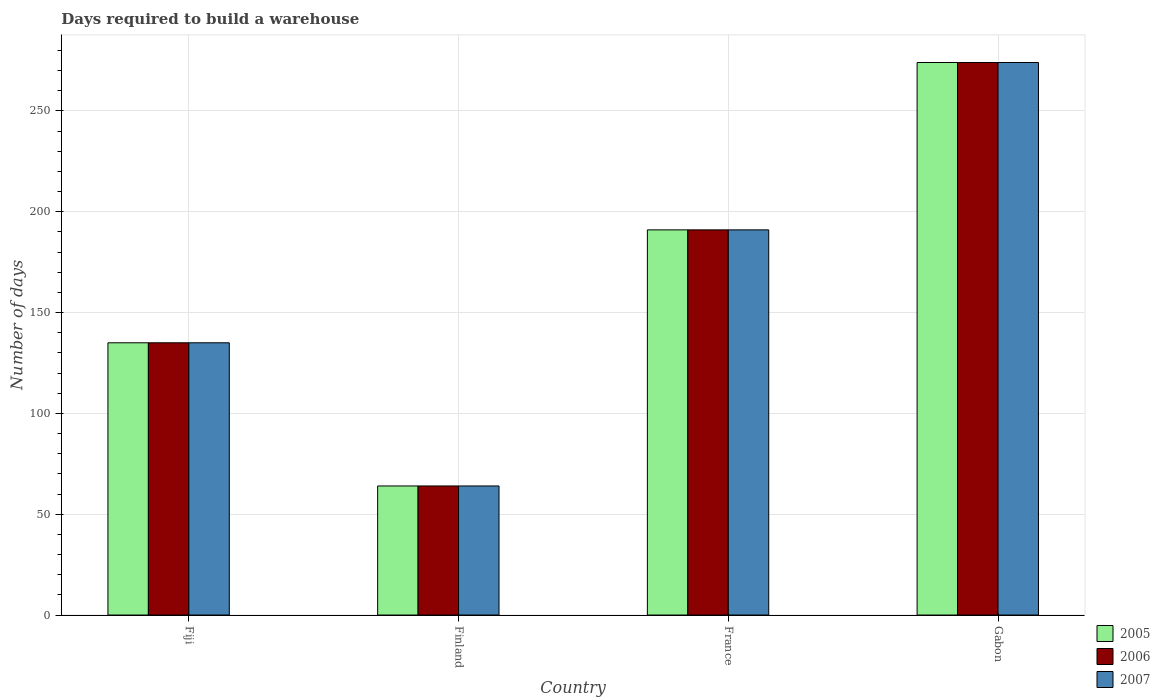Are the number of bars per tick equal to the number of legend labels?
Your answer should be very brief. Yes. How many bars are there on the 4th tick from the left?
Your answer should be compact. 3. What is the label of the 2nd group of bars from the left?
Ensure brevity in your answer.  Finland. In how many cases, is the number of bars for a given country not equal to the number of legend labels?
Offer a very short reply. 0. What is the days required to build a warehouse in in 2006 in Fiji?
Your answer should be very brief. 135. Across all countries, what is the maximum days required to build a warehouse in in 2007?
Keep it short and to the point. 274. Across all countries, what is the minimum days required to build a warehouse in in 2007?
Ensure brevity in your answer.  64. In which country was the days required to build a warehouse in in 2005 maximum?
Provide a short and direct response. Gabon. In which country was the days required to build a warehouse in in 2006 minimum?
Your response must be concise. Finland. What is the total days required to build a warehouse in in 2006 in the graph?
Keep it short and to the point. 664. What is the difference between the days required to build a warehouse in in 2005 in Fiji and that in France?
Your answer should be very brief. -56. What is the difference between the days required to build a warehouse in in 2005 in Gabon and the days required to build a warehouse in in 2006 in Finland?
Your answer should be compact. 210. What is the average days required to build a warehouse in in 2005 per country?
Your answer should be compact. 166. In how many countries, is the days required to build a warehouse in in 2005 greater than 200 days?
Offer a very short reply. 1. What is the ratio of the days required to build a warehouse in in 2007 in Finland to that in France?
Your answer should be compact. 0.34. Is the days required to build a warehouse in in 2005 in Finland less than that in Gabon?
Ensure brevity in your answer.  Yes. What is the difference between the highest and the second highest days required to build a warehouse in in 2006?
Your answer should be very brief. -139. What is the difference between the highest and the lowest days required to build a warehouse in in 2005?
Provide a short and direct response. 210. What does the 1st bar from the left in Finland represents?
Provide a succinct answer. 2005. What does the 2nd bar from the right in Gabon represents?
Your answer should be very brief. 2006. How many bars are there?
Provide a short and direct response. 12. Are the values on the major ticks of Y-axis written in scientific E-notation?
Keep it short and to the point. No. Does the graph contain any zero values?
Your response must be concise. No. Does the graph contain grids?
Ensure brevity in your answer.  Yes. How are the legend labels stacked?
Your response must be concise. Vertical. What is the title of the graph?
Your answer should be very brief. Days required to build a warehouse. Does "2000" appear as one of the legend labels in the graph?
Your response must be concise. No. What is the label or title of the X-axis?
Your answer should be very brief. Country. What is the label or title of the Y-axis?
Give a very brief answer. Number of days. What is the Number of days of 2005 in Fiji?
Keep it short and to the point. 135. What is the Number of days in 2006 in Fiji?
Your answer should be compact. 135. What is the Number of days in 2007 in Fiji?
Your response must be concise. 135. What is the Number of days of 2005 in Finland?
Your answer should be very brief. 64. What is the Number of days of 2005 in France?
Make the answer very short. 191. What is the Number of days in 2006 in France?
Provide a short and direct response. 191. What is the Number of days in 2007 in France?
Your answer should be compact. 191. What is the Number of days of 2005 in Gabon?
Keep it short and to the point. 274. What is the Number of days in 2006 in Gabon?
Your answer should be compact. 274. What is the Number of days in 2007 in Gabon?
Offer a terse response. 274. Across all countries, what is the maximum Number of days in 2005?
Keep it short and to the point. 274. Across all countries, what is the maximum Number of days of 2006?
Give a very brief answer. 274. Across all countries, what is the maximum Number of days in 2007?
Make the answer very short. 274. Across all countries, what is the minimum Number of days of 2007?
Provide a succinct answer. 64. What is the total Number of days of 2005 in the graph?
Keep it short and to the point. 664. What is the total Number of days in 2006 in the graph?
Your answer should be very brief. 664. What is the total Number of days of 2007 in the graph?
Give a very brief answer. 664. What is the difference between the Number of days of 2007 in Fiji and that in Finland?
Make the answer very short. 71. What is the difference between the Number of days of 2005 in Fiji and that in France?
Offer a terse response. -56. What is the difference between the Number of days in 2006 in Fiji and that in France?
Ensure brevity in your answer.  -56. What is the difference between the Number of days in 2007 in Fiji and that in France?
Your response must be concise. -56. What is the difference between the Number of days of 2005 in Fiji and that in Gabon?
Provide a short and direct response. -139. What is the difference between the Number of days of 2006 in Fiji and that in Gabon?
Your answer should be very brief. -139. What is the difference between the Number of days of 2007 in Fiji and that in Gabon?
Offer a very short reply. -139. What is the difference between the Number of days of 2005 in Finland and that in France?
Ensure brevity in your answer.  -127. What is the difference between the Number of days of 2006 in Finland and that in France?
Offer a very short reply. -127. What is the difference between the Number of days of 2007 in Finland and that in France?
Give a very brief answer. -127. What is the difference between the Number of days of 2005 in Finland and that in Gabon?
Your answer should be compact. -210. What is the difference between the Number of days of 2006 in Finland and that in Gabon?
Your answer should be compact. -210. What is the difference between the Number of days of 2007 in Finland and that in Gabon?
Offer a very short reply. -210. What is the difference between the Number of days of 2005 in France and that in Gabon?
Keep it short and to the point. -83. What is the difference between the Number of days in 2006 in France and that in Gabon?
Provide a succinct answer. -83. What is the difference between the Number of days of 2007 in France and that in Gabon?
Give a very brief answer. -83. What is the difference between the Number of days in 2005 in Fiji and the Number of days in 2006 in Finland?
Your answer should be compact. 71. What is the difference between the Number of days of 2005 in Fiji and the Number of days of 2007 in Finland?
Your response must be concise. 71. What is the difference between the Number of days of 2005 in Fiji and the Number of days of 2006 in France?
Provide a succinct answer. -56. What is the difference between the Number of days of 2005 in Fiji and the Number of days of 2007 in France?
Your answer should be compact. -56. What is the difference between the Number of days of 2006 in Fiji and the Number of days of 2007 in France?
Ensure brevity in your answer.  -56. What is the difference between the Number of days of 2005 in Fiji and the Number of days of 2006 in Gabon?
Offer a terse response. -139. What is the difference between the Number of days in 2005 in Fiji and the Number of days in 2007 in Gabon?
Offer a terse response. -139. What is the difference between the Number of days of 2006 in Fiji and the Number of days of 2007 in Gabon?
Ensure brevity in your answer.  -139. What is the difference between the Number of days of 2005 in Finland and the Number of days of 2006 in France?
Your answer should be compact. -127. What is the difference between the Number of days in 2005 in Finland and the Number of days in 2007 in France?
Ensure brevity in your answer.  -127. What is the difference between the Number of days in 2006 in Finland and the Number of days in 2007 in France?
Give a very brief answer. -127. What is the difference between the Number of days of 2005 in Finland and the Number of days of 2006 in Gabon?
Keep it short and to the point. -210. What is the difference between the Number of days in 2005 in Finland and the Number of days in 2007 in Gabon?
Make the answer very short. -210. What is the difference between the Number of days in 2006 in Finland and the Number of days in 2007 in Gabon?
Your response must be concise. -210. What is the difference between the Number of days of 2005 in France and the Number of days of 2006 in Gabon?
Provide a short and direct response. -83. What is the difference between the Number of days of 2005 in France and the Number of days of 2007 in Gabon?
Your response must be concise. -83. What is the difference between the Number of days in 2006 in France and the Number of days in 2007 in Gabon?
Your response must be concise. -83. What is the average Number of days of 2005 per country?
Provide a succinct answer. 166. What is the average Number of days in 2006 per country?
Provide a short and direct response. 166. What is the average Number of days in 2007 per country?
Your answer should be compact. 166. What is the difference between the Number of days of 2005 and Number of days of 2006 in Fiji?
Make the answer very short. 0. What is the difference between the Number of days of 2005 and Number of days of 2007 in Fiji?
Keep it short and to the point. 0. What is the difference between the Number of days of 2006 and Number of days of 2007 in Finland?
Keep it short and to the point. 0. What is the difference between the Number of days in 2005 and Number of days in 2006 in France?
Make the answer very short. 0. What is the difference between the Number of days in 2005 and Number of days in 2007 in Gabon?
Offer a terse response. 0. What is the difference between the Number of days of 2006 and Number of days of 2007 in Gabon?
Your answer should be compact. 0. What is the ratio of the Number of days of 2005 in Fiji to that in Finland?
Provide a succinct answer. 2.11. What is the ratio of the Number of days in 2006 in Fiji to that in Finland?
Make the answer very short. 2.11. What is the ratio of the Number of days of 2007 in Fiji to that in Finland?
Provide a succinct answer. 2.11. What is the ratio of the Number of days of 2005 in Fiji to that in France?
Your response must be concise. 0.71. What is the ratio of the Number of days of 2006 in Fiji to that in France?
Make the answer very short. 0.71. What is the ratio of the Number of days in 2007 in Fiji to that in France?
Make the answer very short. 0.71. What is the ratio of the Number of days in 2005 in Fiji to that in Gabon?
Your response must be concise. 0.49. What is the ratio of the Number of days in 2006 in Fiji to that in Gabon?
Ensure brevity in your answer.  0.49. What is the ratio of the Number of days in 2007 in Fiji to that in Gabon?
Make the answer very short. 0.49. What is the ratio of the Number of days in 2005 in Finland to that in France?
Provide a succinct answer. 0.34. What is the ratio of the Number of days in 2006 in Finland to that in France?
Give a very brief answer. 0.34. What is the ratio of the Number of days of 2007 in Finland to that in France?
Your answer should be very brief. 0.34. What is the ratio of the Number of days in 2005 in Finland to that in Gabon?
Provide a succinct answer. 0.23. What is the ratio of the Number of days of 2006 in Finland to that in Gabon?
Make the answer very short. 0.23. What is the ratio of the Number of days of 2007 in Finland to that in Gabon?
Make the answer very short. 0.23. What is the ratio of the Number of days of 2005 in France to that in Gabon?
Offer a terse response. 0.7. What is the ratio of the Number of days in 2006 in France to that in Gabon?
Keep it short and to the point. 0.7. What is the ratio of the Number of days of 2007 in France to that in Gabon?
Make the answer very short. 0.7. What is the difference between the highest and the second highest Number of days of 2005?
Your answer should be compact. 83. What is the difference between the highest and the second highest Number of days in 2007?
Ensure brevity in your answer.  83. What is the difference between the highest and the lowest Number of days in 2005?
Ensure brevity in your answer.  210. What is the difference between the highest and the lowest Number of days in 2006?
Give a very brief answer. 210. What is the difference between the highest and the lowest Number of days in 2007?
Offer a very short reply. 210. 